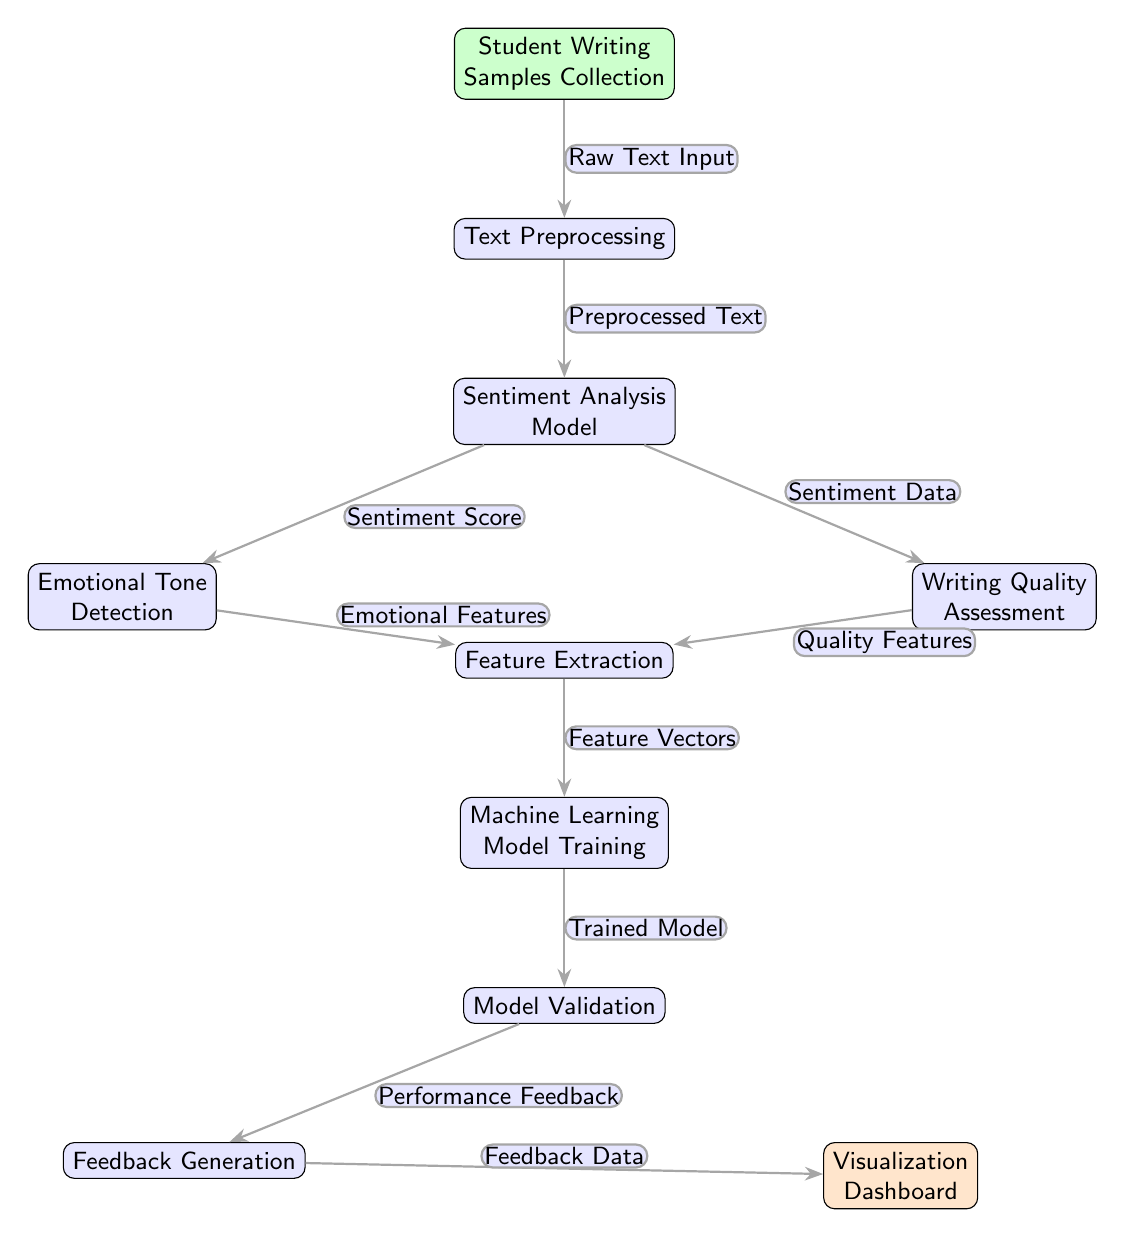What is the first step in the diagram? The first step is represented by the node "Student Writing Samples Collection," which collects the raw writing samples from students.
Answer: Student Writing Samples Collection How many nodes are in the diagram? To find the total number of nodes, count all the distinct boxes in the diagram. There are 10 nodes that represent different steps or processes.
Answer: 10 What does the output of the Sentiment Analysis Model yield? The output of the Sentiment Analysis Model yields two types of data: "Sentiment Score" for emotional tone detection and "Sentiment Data" for writing quality assessment.
Answer: Sentiment Score and Sentiment Data Which process comes directly after Feature Extraction? After Feature Extraction, the process that follows is Machine Learning Model Training, where the model is trained using the extracted features.
Answer: Machine Learning Model Training What is the relationship between Emotional Tone Detection and Feature Extraction? Emotional Tone Detection depends on the Emotional Features generated from the Sentiment Analysis Model, which subsequently flows into Feature Extraction.
Answer: Emotional Features What type of feedback is generated after Model Validation? After Model Validation, the process generates "Performance Feedback," which is utilized to provide insights on the quality and effectiveness of the model.
Answer: Performance Feedback What is the end point of the feedback loop connected to the Visualization Dashboard? The end point of the feedback loop connected to the Visualization Dashboard is "Feedback Data," which is derived from the Feedback Generation process.
Answer: Feedback Data How does preprocessing affect the Sentiment Analysis Model? Preprocessing transforms the "Raw Text Input" into "Preprocessed Text," which is necessary for the Sentiment Analysis Model to function effectively.
Answer: Preprocessed Text Which two assessment categories are identified from sentiment analysis? The two assessment categories identified are "Emotional Tone Detection" and "Writing Quality Assessment," each focusing on different aspects of student writing.
Answer: Emotional Tone Detection and Writing Quality Assessment 